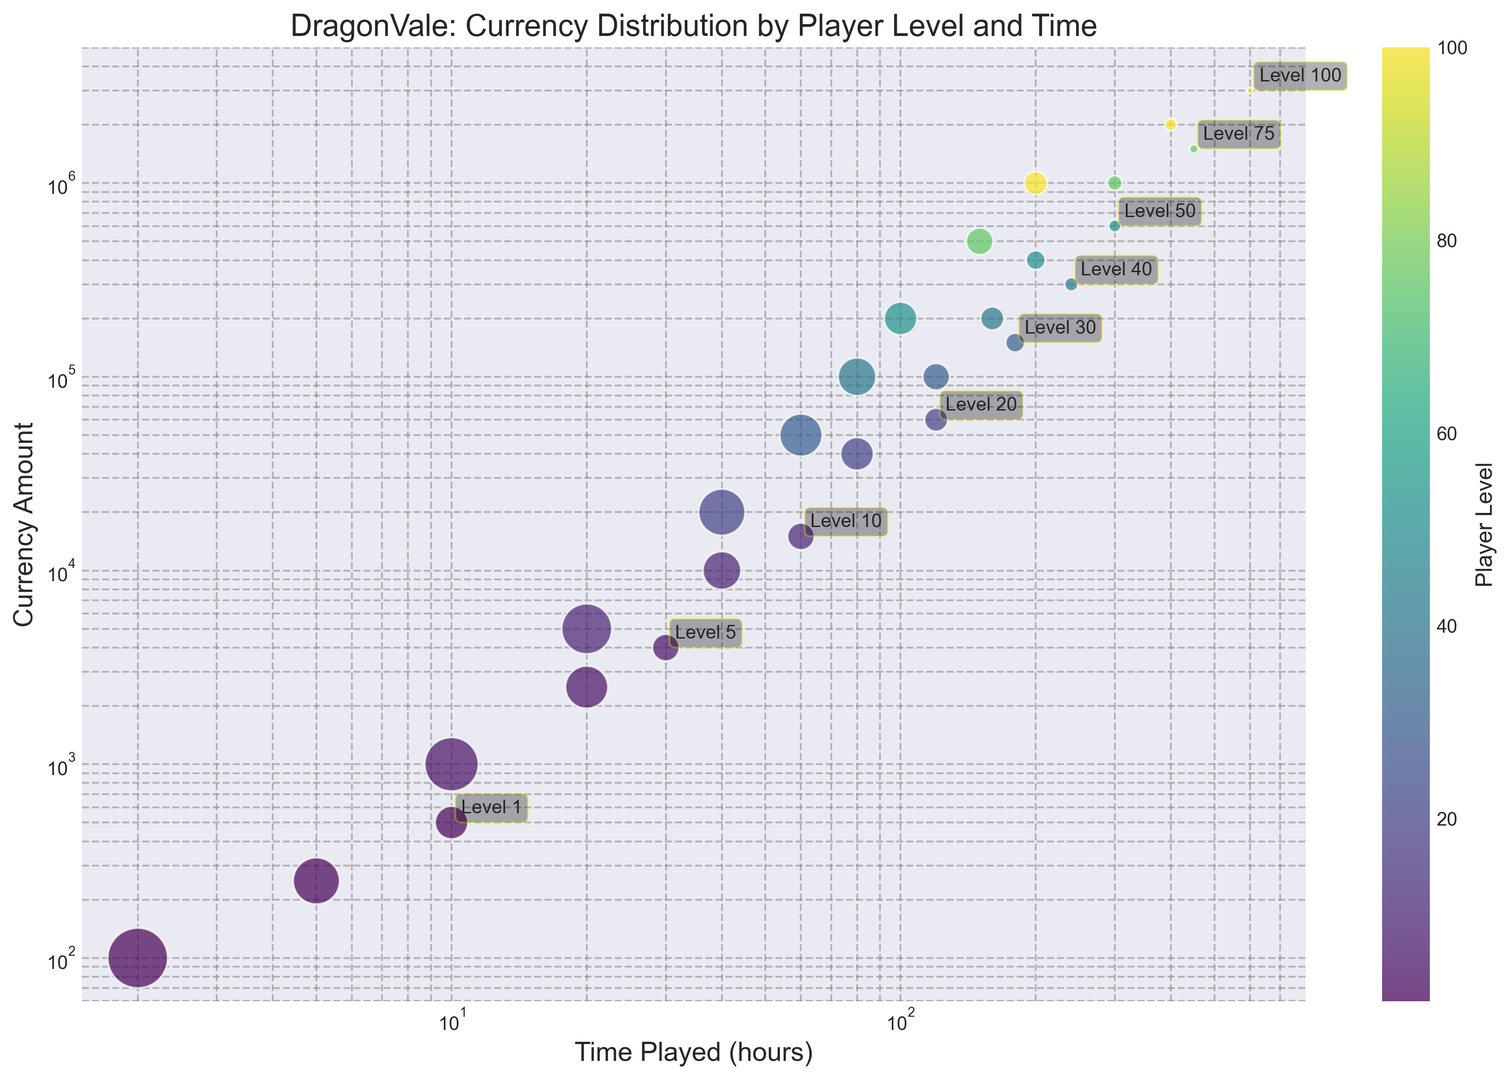How does the amount of in-game currency differ for players who spend the same amount of time (200 hours) in the game but are at different levels? To answer this, look for players who have spent 200 hours in the game and compare the currency amounts. For player levels 50 and 100, the currency amounts are 400,000 and 2,000,000 respectively.
Answer: The level 100 player has 2,000,000 currency, and the level 50 player has 400,000 currency Which player level shows the highest in-game currency, and how much is it? Look at the figure and identify the bubble with the highest position on the y-axis, which would indicate the highest in-game currency amount. The bubble at the top corresponds to level 100.
Answer: Level 100, 3,000,000 currency For a player at level 20, what is the increase in in-game currency from 40 hours to 80 hours of gameplay? Find the bubbles for level 20 and note the currency amounts at 40 hours and 80 hours. The currency increases from 20,000 to 40,000.
Answer: Increase of 20,000 currency Are there more players with 100,000 in-game currency at level 30 or level 40? Check the size of the bubbles at the 100,000 currency mark for levels 30 and 40. The bubble for level 30 is larger, indicating more players.
Answer: More players at level 30 What is the average amount of in-game currency for level 5 players? Identify the three bubbles at level 5 and their respective currency amounts (1,000, 2,500, 4,000). Calculate the average: (1,000 + 2,500 + 4,000) / 3 = 2,500.
Answer: 2,500 currency Compare the in-game currency amounts for players at level 1 who spent 5 hours and 10 hours in the game. How much more currency does the latter group have? For level 1, compare the currency at 5 hours and 10 hours. Players at 5 hours have 250 currency, while those at 10 hours have 500 currency. The difference is 500 - 250 = 250.
Answer: 250 more currency What's the difference in in-game currency between the largest and smallest bubbles at level 75? Identify the largest and smallest bubbles at level 75. The largest bubble has 1,500,000 currency, and the smallest has 500,000 currency. The difference is 1,500,000 - 500,000 = 1,000,000.
Answer: Difference of 1,000,000 currency What can we infer about the player distribution for level 10 who play for 60 hours compared to those who play for 20 hours? Look at the size of the bubbles for level 10 at 60 hours (100 players) and 20 hours (350 players). The bubble for 20 hours is larger, indicating more players.
Answer: More players at 20 hours Which level has players with the least amount of in-game currency, and how much is it? Identify the bubble at the lowest position on the y-axis, which is level 1 with an in-game currency amount of 100.
Answer: Level 1, 100 currency 